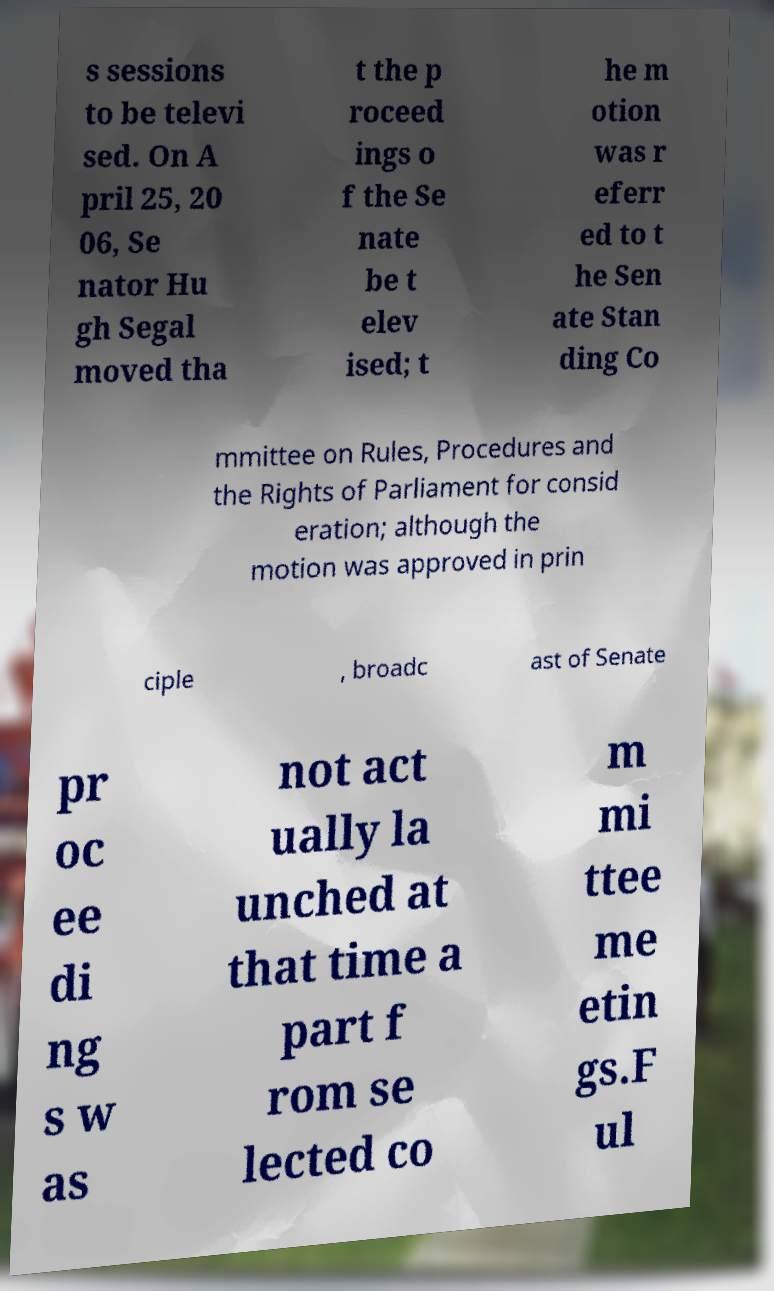Can you read and provide the text displayed in the image?This photo seems to have some interesting text. Can you extract and type it out for me? s sessions to be televi sed. On A pril 25, 20 06, Se nator Hu gh Segal moved tha t the p roceed ings o f the Se nate be t elev ised; t he m otion was r eferr ed to t he Sen ate Stan ding Co mmittee on Rules, Procedures and the Rights of Parliament for consid eration; although the motion was approved in prin ciple , broadc ast of Senate pr oc ee di ng s w as not act ually la unched at that time a part f rom se lected co m mi ttee me etin gs.F ul 